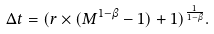Convert formula to latex. <formula><loc_0><loc_0><loc_500><loc_500>\Delta t = ( r \times ( M ^ { 1 - \beta } - 1 ) + 1 ) ^ { \frac { 1 } { 1 - \beta } } .</formula> 